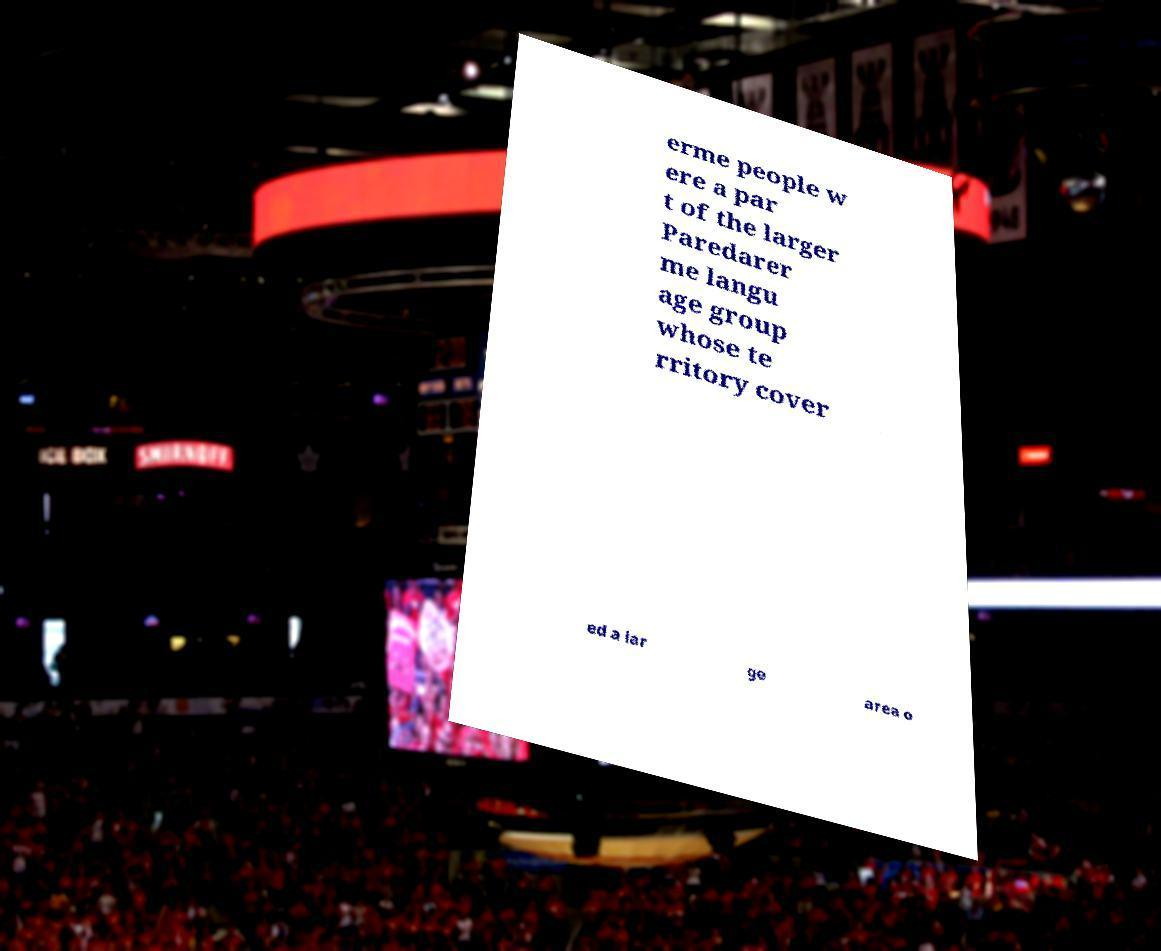Could you assist in decoding the text presented in this image and type it out clearly? erme people w ere a par t of the larger Paredarer me langu age group whose te rritory cover ed a lar ge area o 